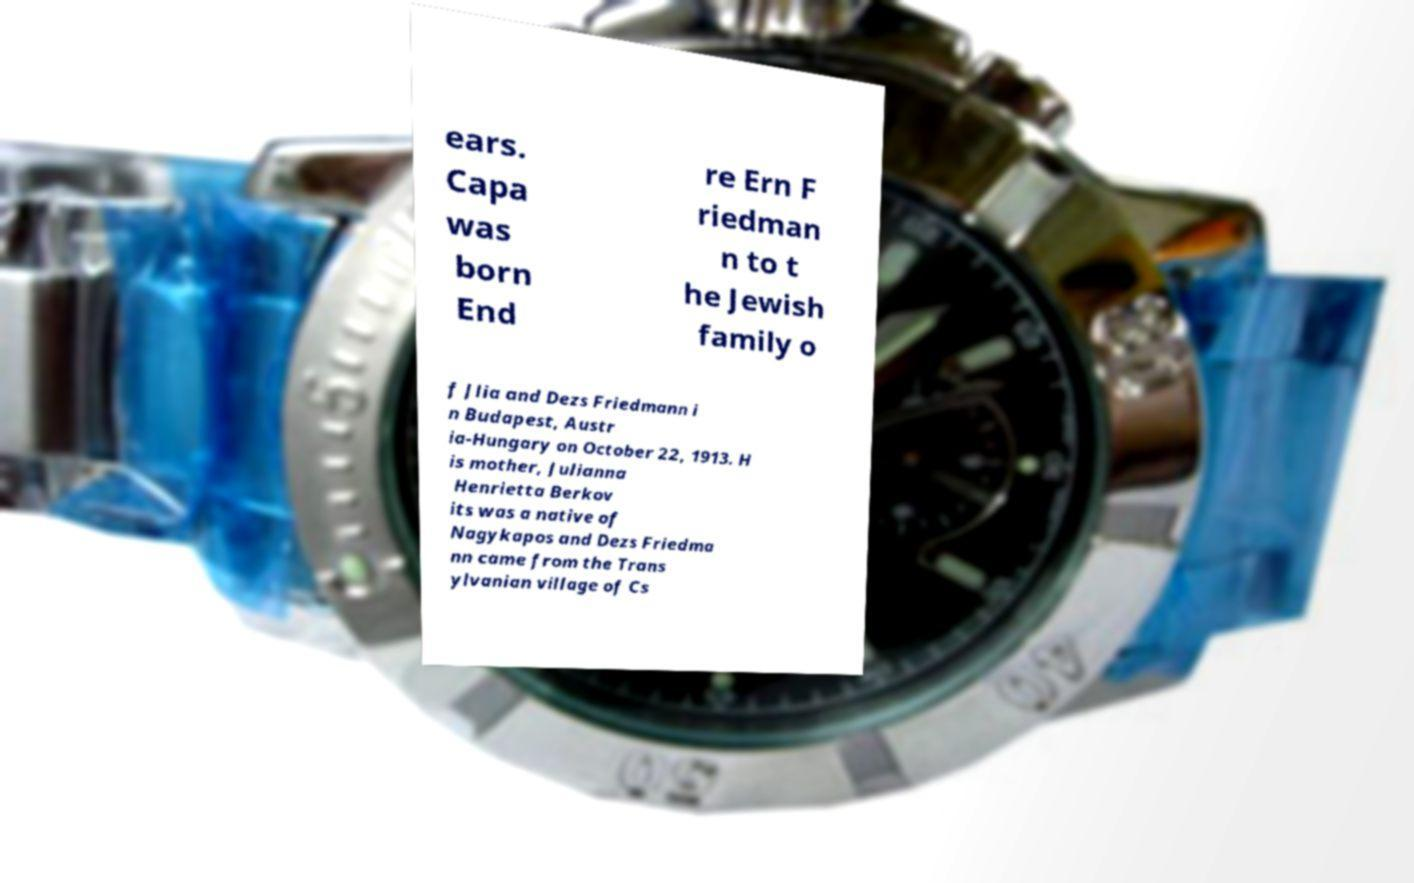For documentation purposes, I need the text within this image transcribed. Could you provide that? ears. Capa was born End re Ern F riedman n to t he Jewish family o f Jlia and Dezs Friedmann i n Budapest, Austr ia-Hungary on October 22, 1913. H is mother, Julianna Henrietta Berkov its was a native of Nagykapos and Dezs Friedma nn came from the Trans ylvanian village of Cs 